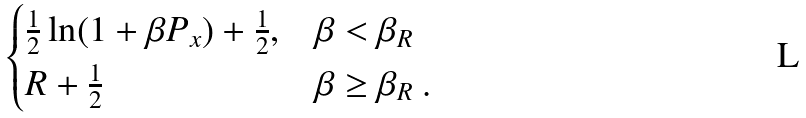<formula> <loc_0><loc_0><loc_500><loc_500>\begin{cases} \frac { 1 } { 2 } \ln ( 1 + \beta P _ { x } ) + \frac { 1 } { 2 } , & \beta < \beta _ { R } \\ R + \frac { 1 } { 2 } & \beta \geq \beta _ { R } \ . \end{cases}</formula> 